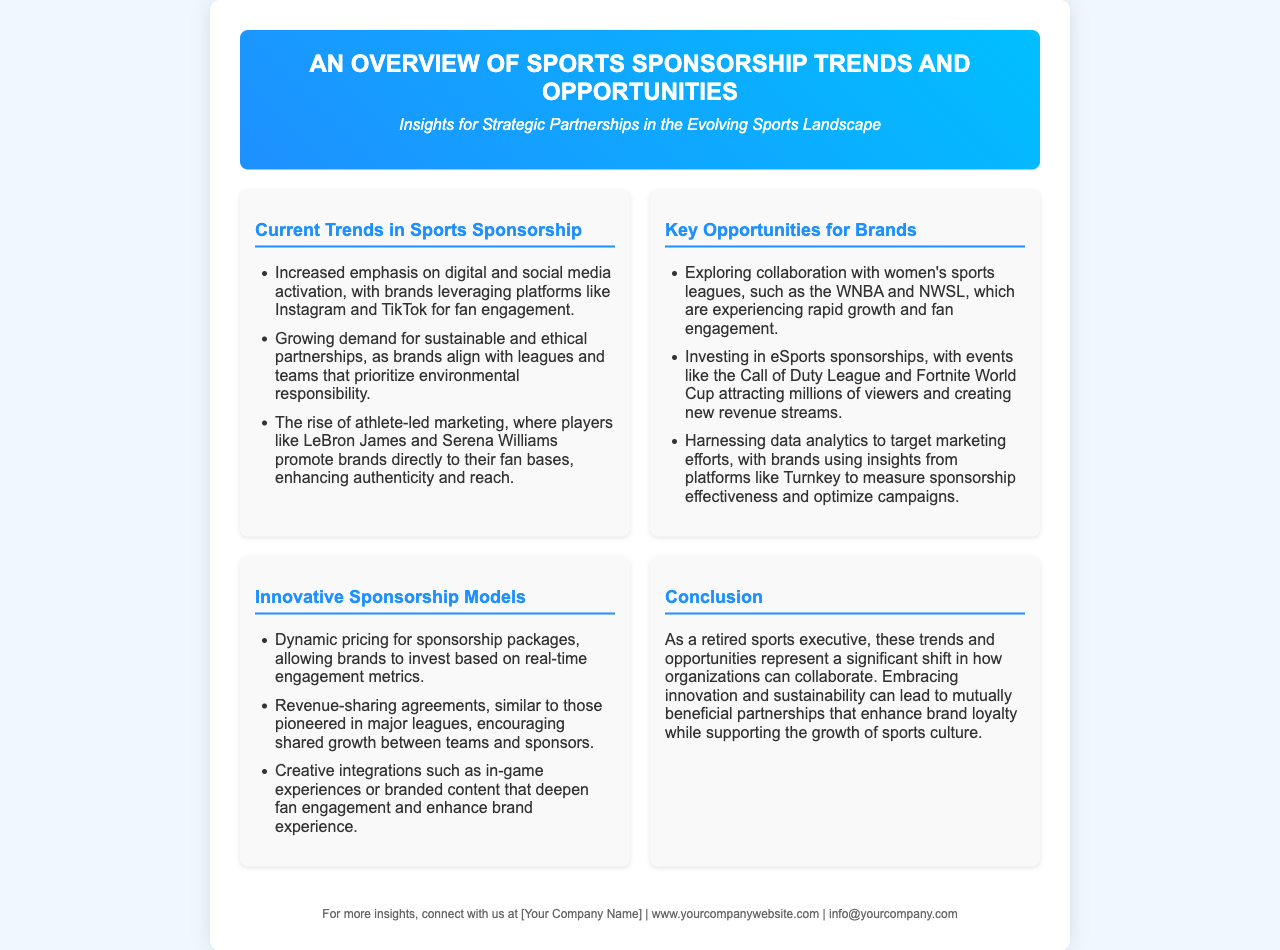What is the title of the brochure? The title of the brochure is presented clearly at the top of the document.
Answer: An Overview of Sports Sponsorship Trends and Opportunities What are the current trends in sports sponsorship? The document lists several trends, specifically in the section dedicated to current trends.
Answer: Increased emphasis on digital and social media activation What is one key opportunity for brands mentioned? The brochure outlines multiple opportunities for brands in a specific section.
Answer: Exploring collaboration with women's sports leagues What innovative sponsorship model is highlighted? The document describes various innovative models in a dedicated section.
Answer: Revenue-sharing agreements Who are two athletes mentioned in relation to athlete-led marketing? The trends mention specific athlete names to highlight marketing strategies.
Answer: LeBron James and Serena Williams What is emphasized as a growing demand in partnerships? The current trends section discusses various demands in sponsorships.
Answer: Sustainable and ethical partnerships What type of insights do brands use to measure sponsorship effectiveness? The key opportunities section mentions specific tools used for effectiveness measurement.
Answer: Data analytics What is the focus of the conclusion in the brochure? The conclusion summarizes the overall perspective towards partnerships in sports.
Answer: Embracing innovation and sustainability 